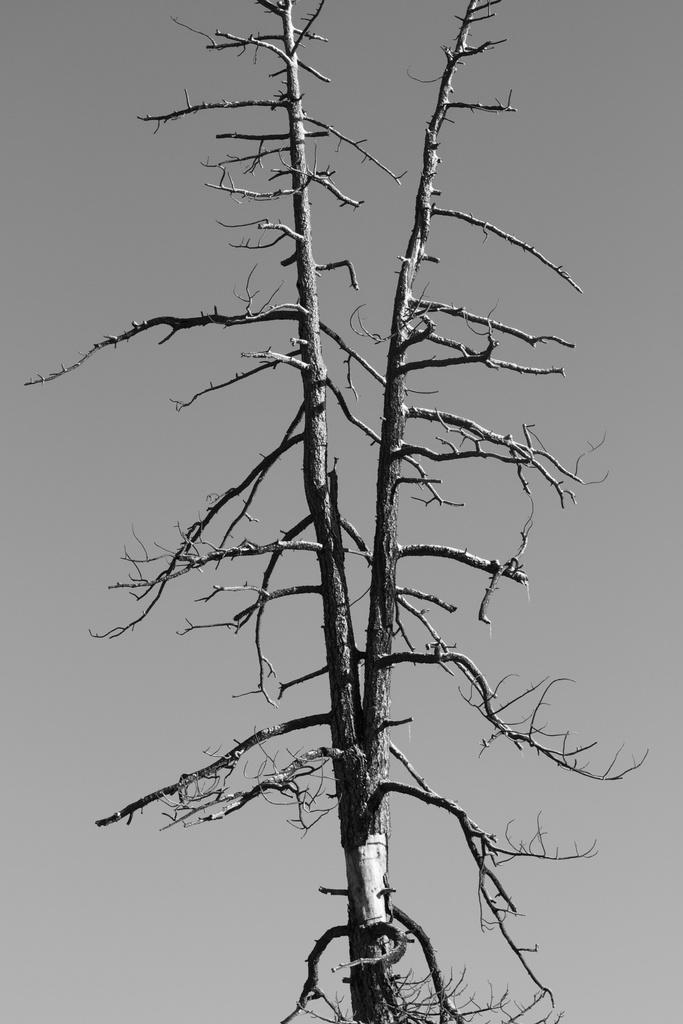Describe this image in one or two sentences. This is a black and white image. We can see a dried tree. We can also see the background. 